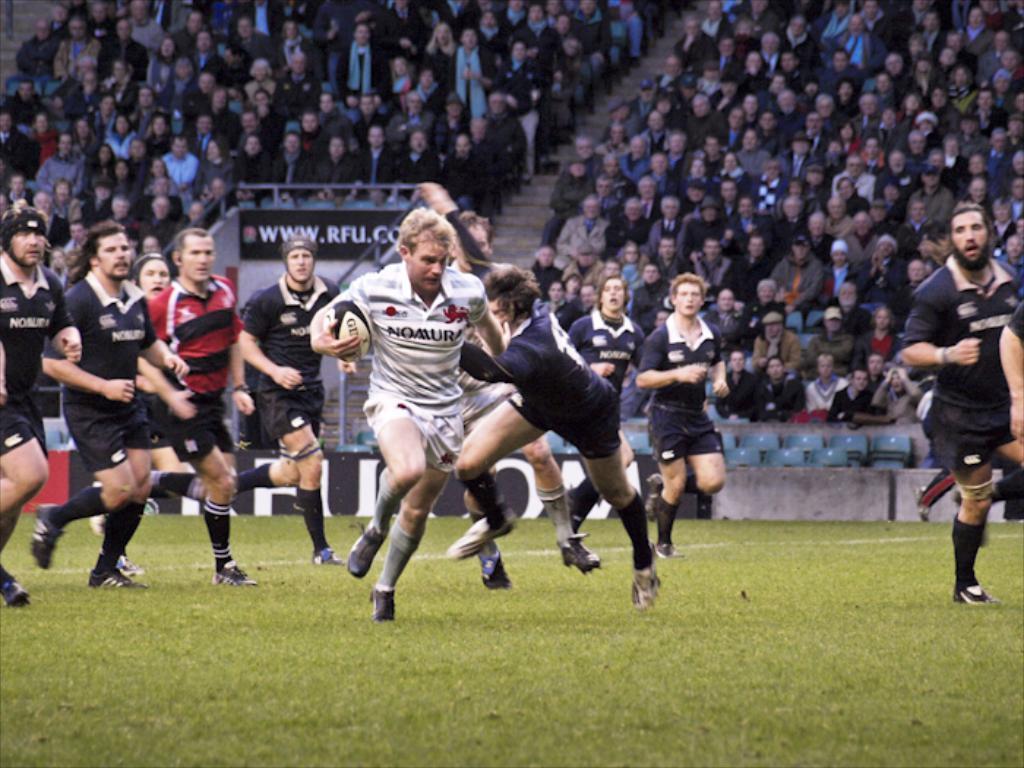How would you summarize this image in a sentence or two? In this picture we can see a group of sports people on the floor wearing jerseys and behind them there are some people sitting on the chairs. 